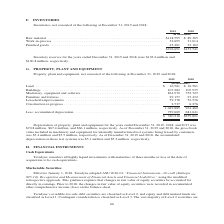According to Teradyne's financial document, What was the amount of Depreciation of property, plant and equipment in 2019? According to the financial document, $70.8 million. The relevant text states: "years ended December 31, 2019, 2018, and 2017 was $70.8 million, $67.4 million, and $66.1 million, respectively. As of December 31, 2019 and 2018, the gross book v..." Also, What was the accumulated depreciation on the test systems in 2019? According to the financial document, $5.1 million. The relevant text states: "accumulated depreciation on these test systems was $5.1 million and $5.2 million, respectively...." Also, In which years was Property, plant and equipment, net calculated? The document shows two values: 2019 and 2018. From the document: "2019 2018 2019 2018..." Additionally, In which year was Construction in progress larger? According to the financial document, 2018. The relevant text states: "2019 2018..." Also, can you calculate: What was the change in the amount of Land from 2018 to 2019? I cannot find a specific answer to this question in the financial document. Also, can you calculate: What was the percentage change in the amount of Land from 2018 to 2019? I cannot find a specific answer to this question in the financial document. 